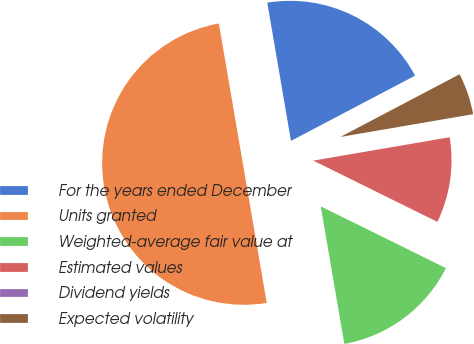Convert chart. <chart><loc_0><loc_0><loc_500><loc_500><pie_chart><fcel>For the years ended December<fcel>Units granted<fcel>Weighted-average fair value at<fcel>Estimated values<fcel>Dividend yields<fcel>Expected volatility<nl><fcel>20.0%<fcel>50.0%<fcel>15.0%<fcel>10.0%<fcel>0.0%<fcel>5.0%<nl></chart> 